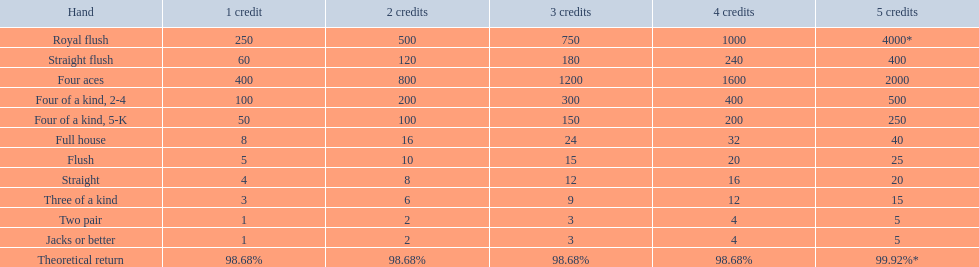Would you mind parsing the complete table? {'header': ['Hand', '1 credit', '2 credits', '3 credits', '4 credits', '5 credits'], 'rows': [['Royal flush', '250', '500', '750', '1000', '4000*'], ['Straight flush', '60', '120', '180', '240', '400'], ['Four aces', '400', '800', '1200', '1600', '2000'], ['Four of a kind, 2-4', '100', '200', '300', '400', '500'], ['Four of a kind, 5-K', '50', '100', '150', '200', '250'], ['Full house', '8', '16', '24', '32', '40'], ['Flush', '5', '10', '15', '20', '25'], ['Straight', '4', '8', '12', '16', '20'], ['Three of a kind', '3', '6', '9', '12', '15'], ['Two pair', '1', '2', '3', '4', '5'], ['Jacks or better', '1', '2', '3', '4', '5'], ['Theoretical return', '98.68%', '98.68%', '98.68%', '98.68%', '99.92%*']]} What are the hands in super aces? Royal flush, Straight flush, Four aces, Four of a kind, 2-4, Four of a kind, 5-K, Full house, Flush, Straight, Three of a kind, Two pair, Jacks or better. What hand gives the highest credits? Royal flush. What are the hands? Royal flush, Straight flush, Four aces, Four of a kind, 2-4, Four of a kind, 5-K, Full house, Flush, Straight, Three of a kind, Two pair, Jacks or better. Which hand is on the upper side? Royal flush. 